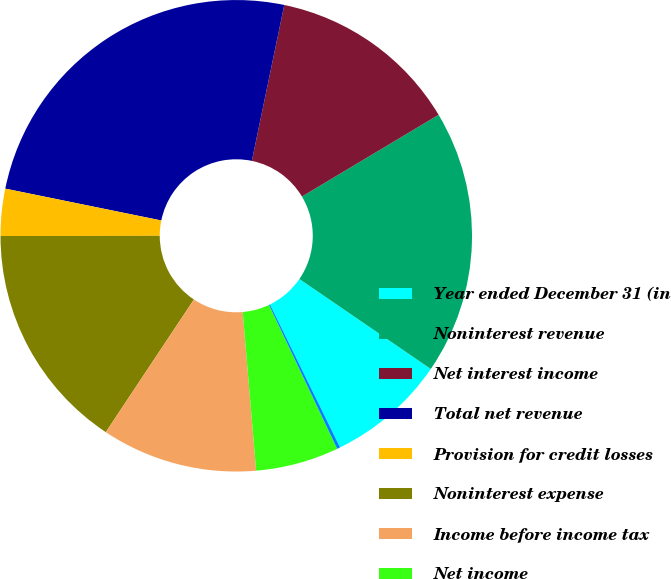Convert chart. <chart><loc_0><loc_0><loc_500><loc_500><pie_chart><fcel>Year ended December 31 (in<fcel>Noninterest revenue<fcel>Net interest income<fcel>Total net revenue<fcel>Provision for credit losses<fcel>Noninterest expense<fcel>Income before income tax<fcel>Net income<fcel>Overhead ratio<nl><fcel>8.19%<fcel>18.13%<fcel>13.16%<fcel>25.06%<fcel>3.22%<fcel>15.65%<fcel>10.68%<fcel>5.7%<fcel>0.21%<nl></chart> 